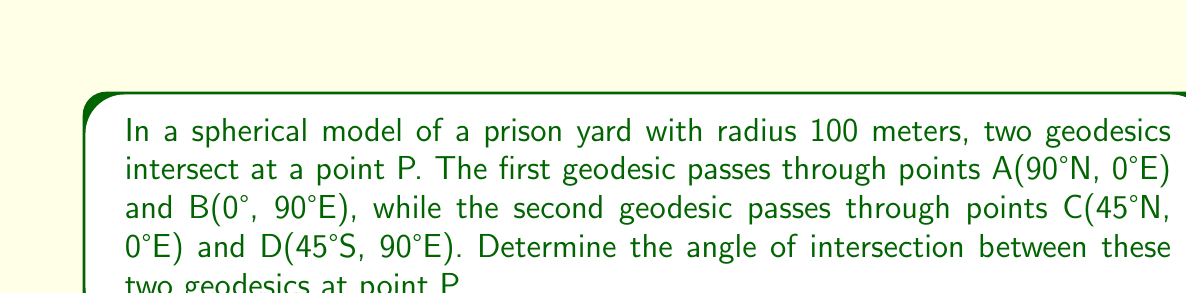What is the answer to this math problem? Let's approach this step-by-step:

1) First, we need to find the coordinates of point P. It's the intersection of the two geodesics.

   - The first geodesic (AB) is along a great circle that passes through the North Pole and the equator at 90°E.
   - The second geodesic (CD) is along a great circle that makes a 45° angle with the equator.

   P is located at (45°N, 45°E).

2) To find the angle of intersection, we need to calculate the normal vectors to each geodesic at P.

3) For geodesic AB:
   $$\vec{n}_1 = (-\sin 45°, \cos 45°, 0) = (-\frac{\sqrt{2}}{2}, \frac{\sqrt{2}}{2}, 0)$$

4) For geodesic CD:
   $$\vec{n}_2 = (-\sin 45° \cdot \sin 45°, -\sin 45° \cdot \cos 45°, \cos 45°)$$
   $$= (-\frac{1}{2}, -\frac{1}{2}, \frac{\sqrt{2}}{2})$$

5) The angle between these normal vectors is the same as the angle between the geodesics. We can find this using the dot product formula:

   $$\cos \theta = \frac{\vec{n}_1 \cdot \vec{n}_2}{|\vec{n}_1||\vec{n}_2|}$$

6) Calculating the dot product:
   $$\vec{n}_1 \cdot \vec{n}_2 = (-\frac{\sqrt{2}}{2})(-\frac{1}{2}) + (\frac{\sqrt{2}}{2})(-\frac{1}{2}) + 0 = 0$$

7) The magnitude of both vectors is 1, so:

   $$\cos \theta = \frac{0}{1 \cdot 1} = 0$$

8) Therefore:
   $$\theta = \arccos(0) = 90°$$
Answer: 90° 